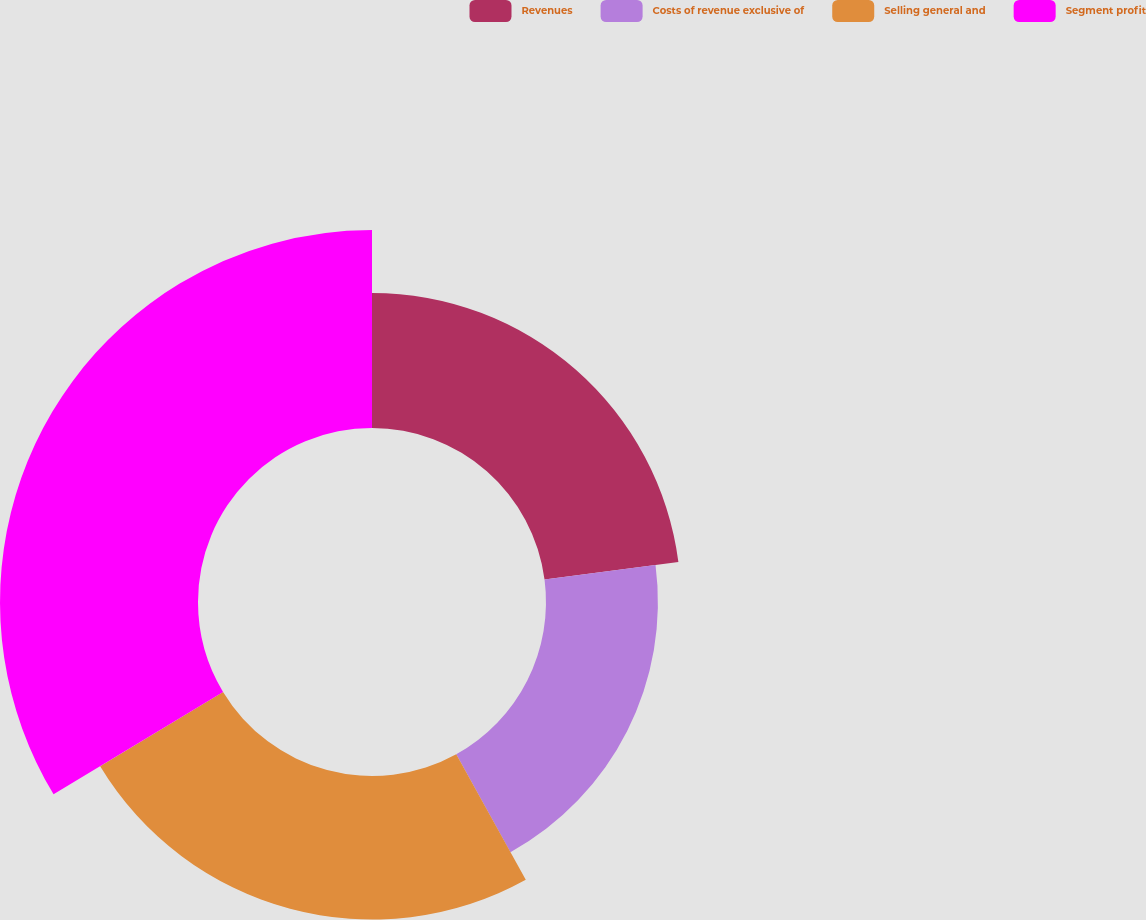Convert chart. <chart><loc_0><loc_0><loc_500><loc_500><pie_chart><fcel>Revenues<fcel>Costs of revenue exclusive of<fcel>Selling general and<fcel>Segment profit<nl><fcel>22.94%<fcel>19.02%<fcel>24.4%<fcel>33.65%<nl></chart> 